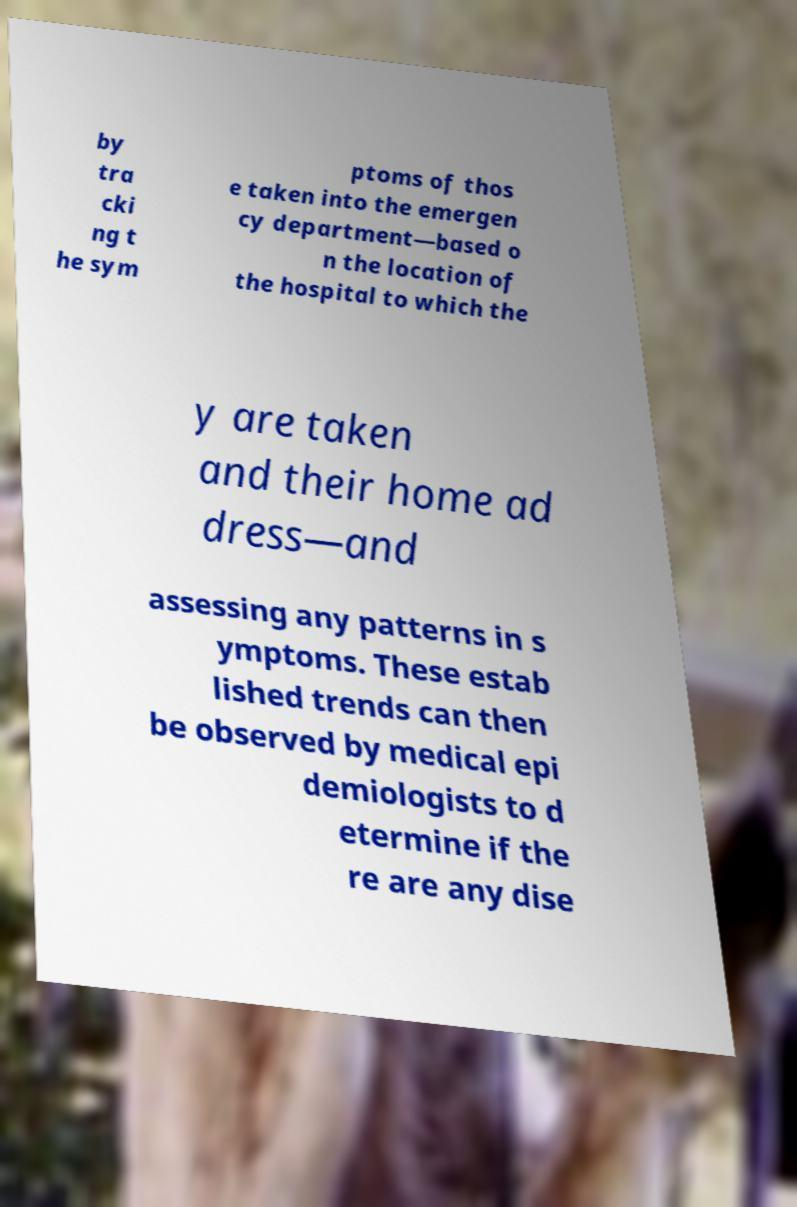There's text embedded in this image that I need extracted. Can you transcribe it verbatim? by tra cki ng t he sym ptoms of thos e taken into the emergen cy department—based o n the location of the hospital to which the y are taken and their home ad dress—and assessing any patterns in s ymptoms. These estab lished trends can then be observed by medical epi demiologists to d etermine if the re are any dise 